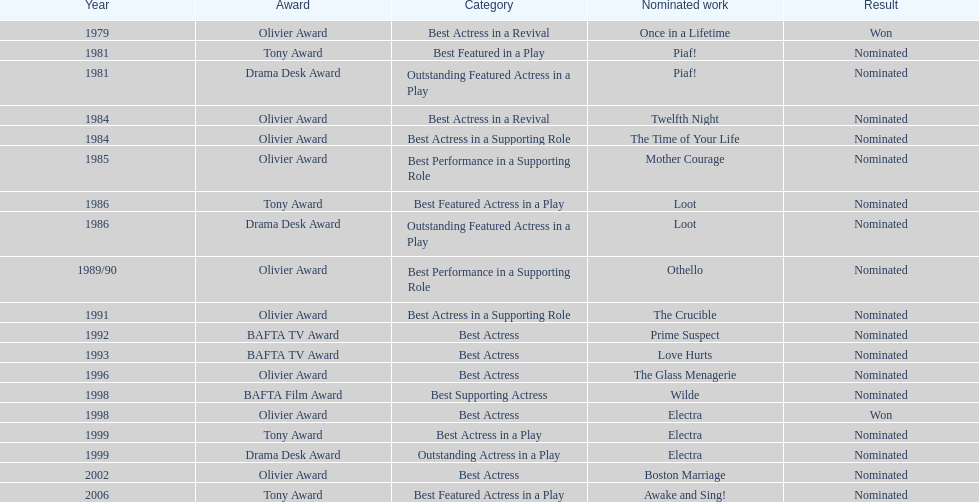What play was wanamaker nominated for best featured in a play in 1981? Piaf!. 